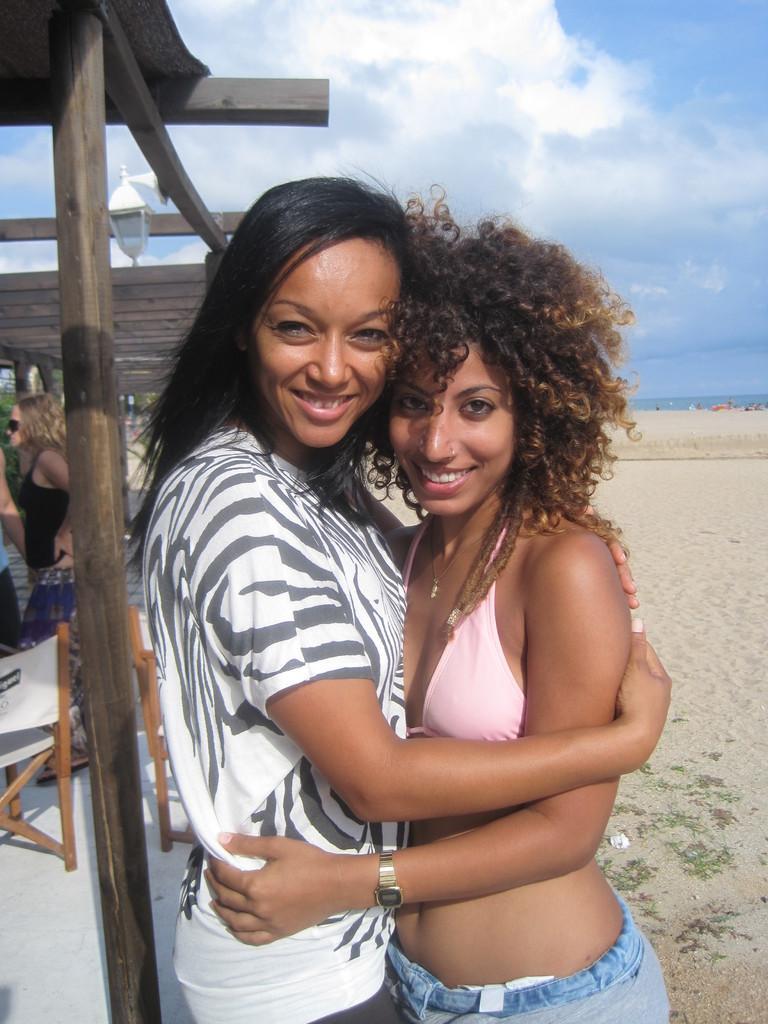Could you give a brief overview of what you see in this image? In this image I can see two women are standing. I can also see smile on their faces. In the background I can see few chairs, few more people, sand, clouds, the sky and here I can see a light. 